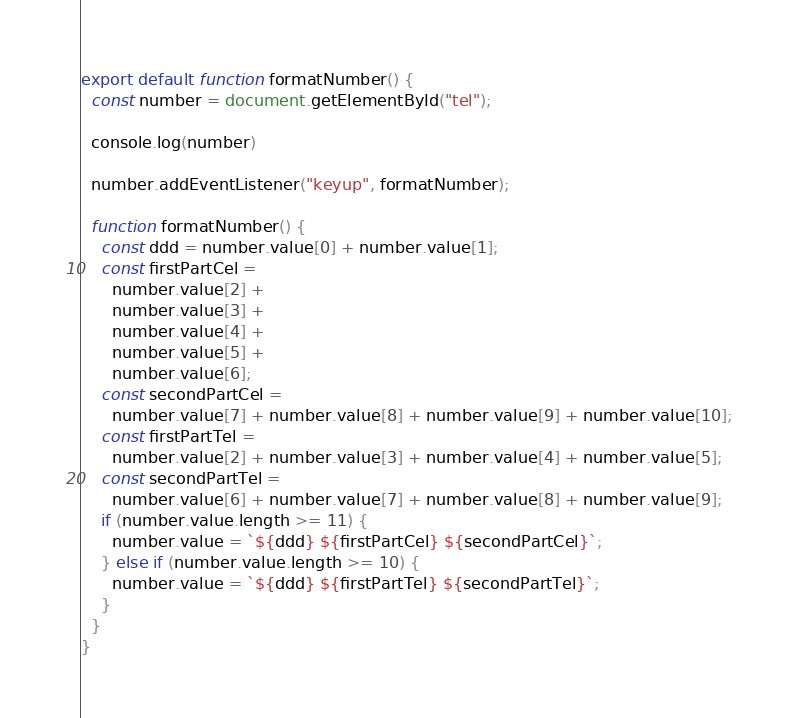Convert code to text. <code><loc_0><loc_0><loc_500><loc_500><_JavaScript_>export default function formatNumber() {
  const number = document.getElementById("tel");

  console.log(number)

  number.addEventListener("keyup", formatNumber);

  function formatNumber() {
    const ddd = number.value[0] + number.value[1];
    const firstPartCel =
      number.value[2] +
      number.value[3] +
      number.value[4] +
      number.value[5] +
      number.value[6];
    const secondPartCel =
      number.value[7] + number.value[8] + number.value[9] + number.value[10];
    const firstPartTel =
      number.value[2] + number.value[3] + number.value[4] + number.value[5];
    const secondPartTel =
      number.value[6] + number.value[7] + number.value[8] + number.value[9];
    if (number.value.length >= 11) {
      number.value = `${ddd} ${firstPartCel} ${secondPartCel}`;
    } else if (number.value.length >= 10) {
      number.value = `${ddd} ${firstPartTel} ${secondPartTel}`;
    }
  }
}</code> 